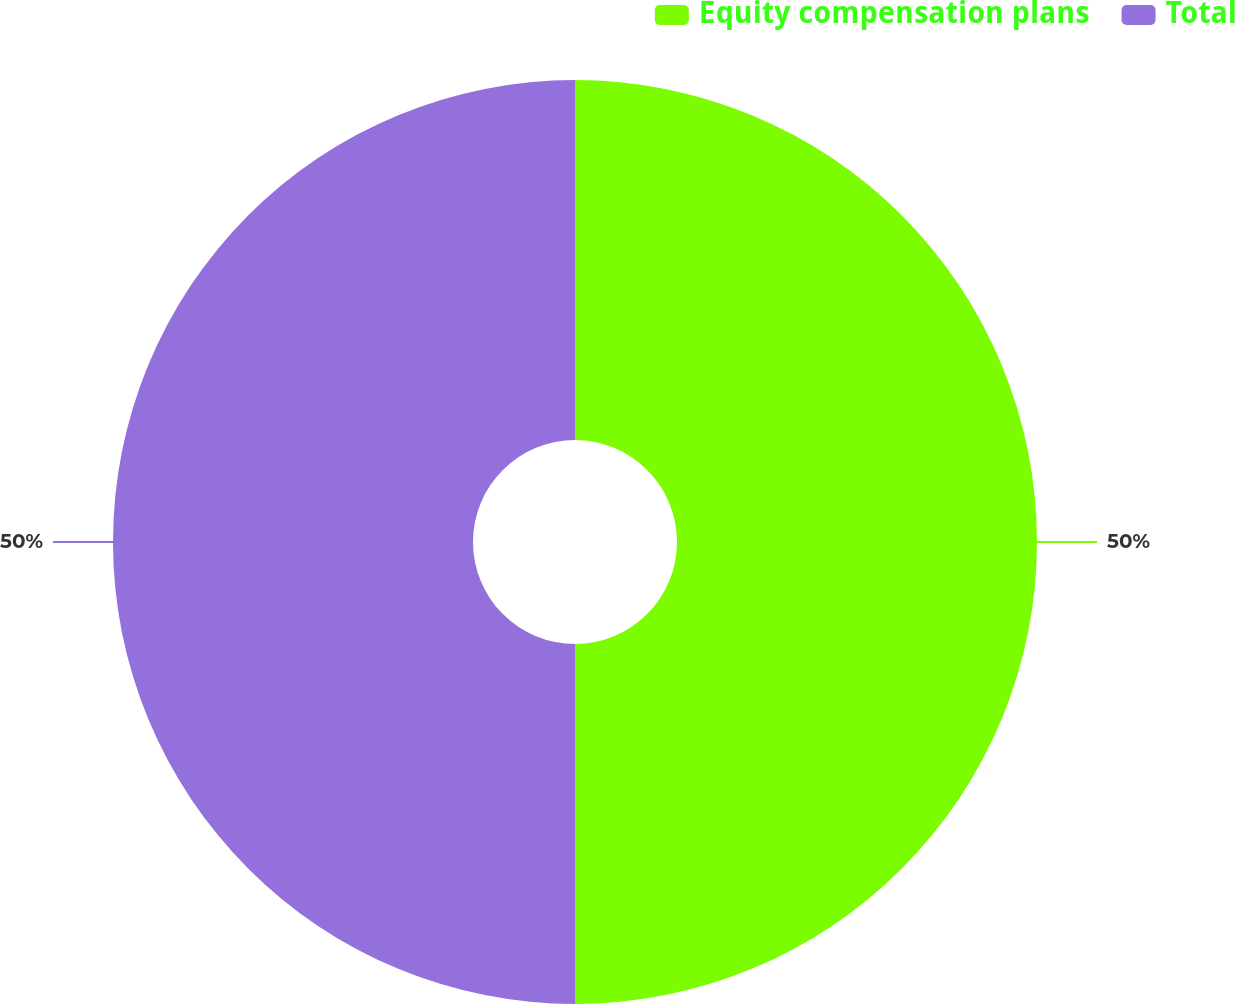Convert chart to OTSL. <chart><loc_0><loc_0><loc_500><loc_500><pie_chart><fcel>Equity compensation plans<fcel>Total<nl><fcel>50.0%<fcel>50.0%<nl></chart> 